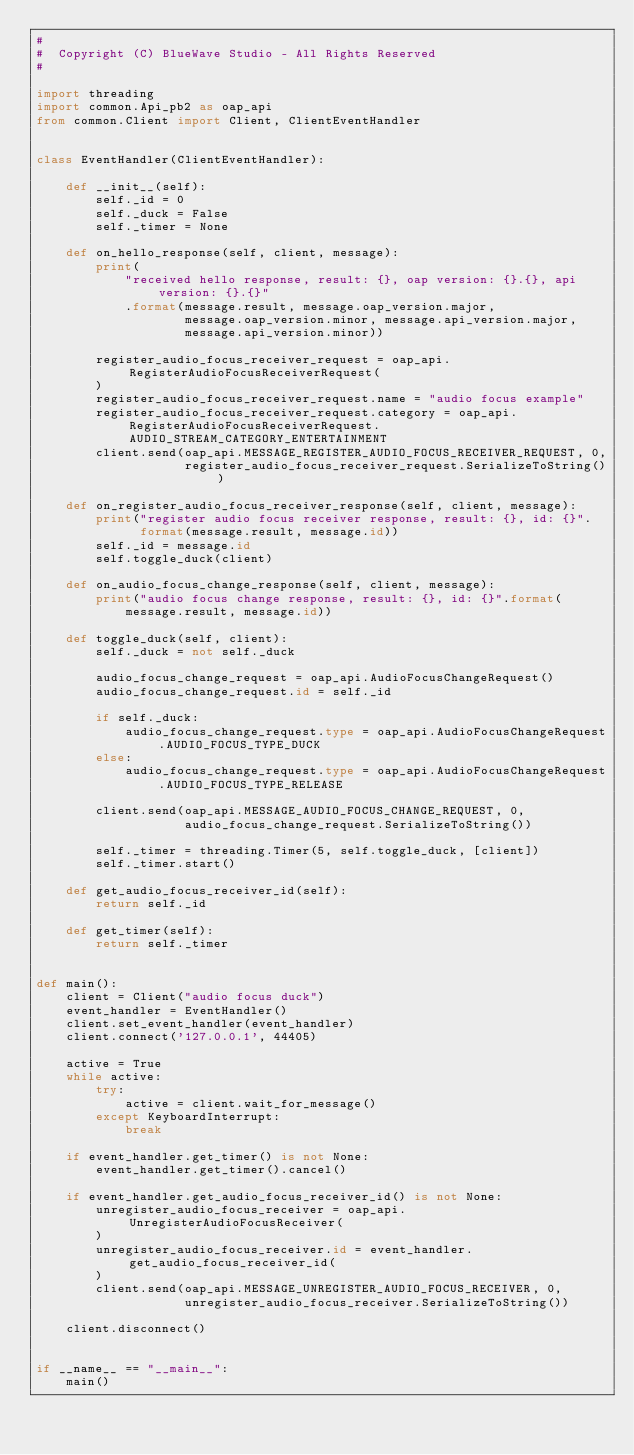<code> <loc_0><loc_0><loc_500><loc_500><_Python_>#
#  Copyright (C) BlueWave Studio - All Rights Reserved
#

import threading
import common.Api_pb2 as oap_api
from common.Client import Client, ClientEventHandler


class EventHandler(ClientEventHandler):

    def __init__(self):
        self._id = 0
        self._duck = False
        self._timer = None

    def on_hello_response(self, client, message):
        print(
            "received hello response, result: {}, oap version: {}.{}, api version: {}.{}"
            .format(message.result, message.oap_version.major,
                    message.oap_version.minor, message.api_version.major,
                    message.api_version.minor))

        register_audio_focus_receiver_request = oap_api.RegisterAudioFocusReceiverRequest(
        )
        register_audio_focus_receiver_request.name = "audio focus example"
        register_audio_focus_receiver_request.category = oap_api.RegisterAudioFocusReceiverRequest.AUDIO_STREAM_CATEGORY_ENTERTAINMENT
        client.send(oap_api.MESSAGE_REGISTER_AUDIO_FOCUS_RECEIVER_REQUEST, 0,
                    register_audio_focus_receiver_request.SerializeToString())

    def on_register_audio_focus_receiver_response(self, client, message):
        print("register audio focus receiver response, result: {}, id: {}".
              format(message.result, message.id))
        self._id = message.id
        self.toggle_duck(client)

    def on_audio_focus_change_response(self, client, message):
        print("audio focus change response, result: {}, id: {}".format(
            message.result, message.id))

    def toggle_duck(self, client):
        self._duck = not self._duck

        audio_focus_change_request = oap_api.AudioFocusChangeRequest()
        audio_focus_change_request.id = self._id

        if self._duck:
            audio_focus_change_request.type = oap_api.AudioFocusChangeRequest.AUDIO_FOCUS_TYPE_DUCK
        else:
            audio_focus_change_request.type = oap_api.AudioFocusChangeRequest.AUDIO_FOCUS_TYPE_RELEASE

        client.send(oap_api.MESSAGE_AUDIO_FOCUS_CHANGE_REQUEST, 0,
                    audio_focus_change_request.SerializeToString())

        self._timer = threading.Timer(5, self.toggle_duck, [client])
        self._timer.start()

    def get_audio_focus_receiver_id(self):
        return self._id

    def get_timer(self):
        return self._timer


def main():
    client = Client("audio focus duck")
    event_handler = EventHandler()
    client.set_event_handler(event_handler)
    client.connect('127.0.0.1', 44405)

    active = True
    while active:
        try:
            active = client.wait_for_message()
        except KeyboardInterrupt:
            break

    if event_handler.get_timer() is not None:
        event_handler.get_timer().cancel()

    if event_handler.get_audio_focus_receiver_id() is not None:
        unregister_audio_focus_receiver = oap_api.UnregisterAudioFocusReceiver(
        )
        unregister_audio_focus_receiver.id = event_handler.get_audio_focus_receiver_id(
        )
        client.send(oap_api.MESSAGE_UNREGISTER_AUDIO_FOCUS_RECEIVER, 0,
                    unregister_audio_focus_receiver.SerializeToString())

    client.disconnect()


if __name__ == "__main__":
    main()
</code> 